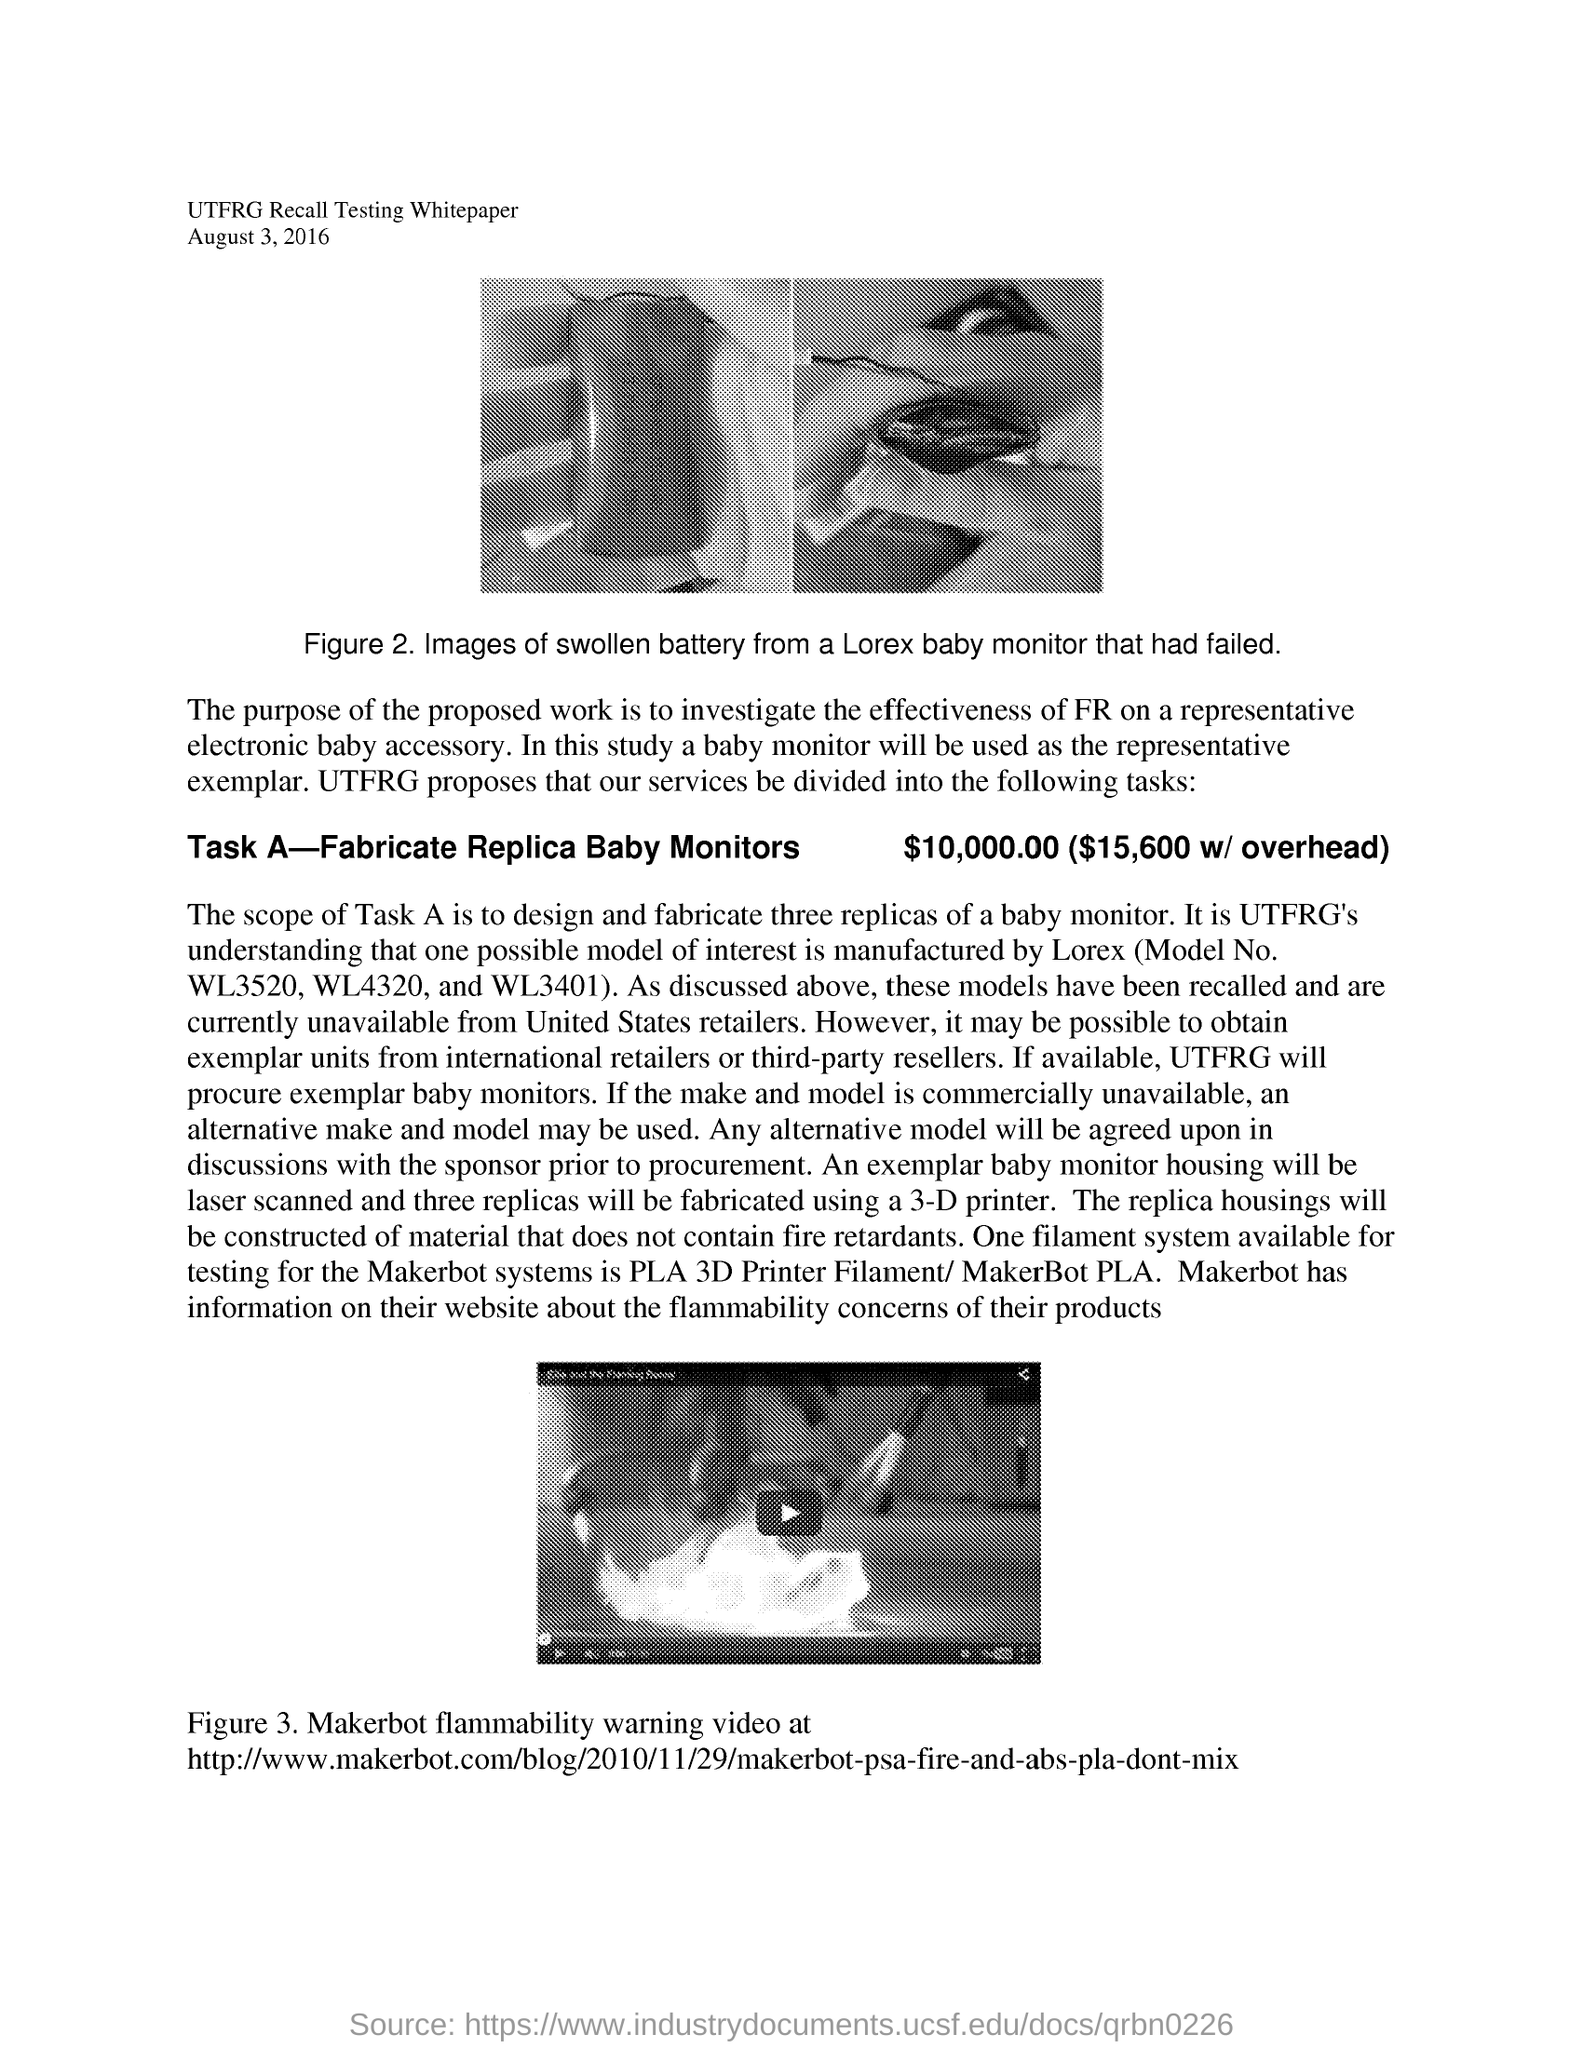Specify some key components in this picture. The date mentioned is August 3, 2016. Task A involves fabricating replica baby monitors. The Figure 3 graphic depicts a Makerbot flammability warning video. 